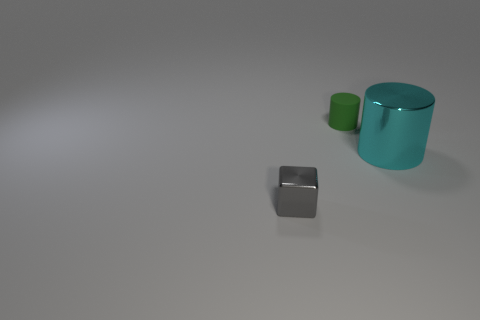The shiny thing that is right of the tiny object that is on the left side of the small green object is what color?
Offer a terse response. Cyan. What size is the object that is behind the tiny shiny cube and left of the large metallic cylinder?
Offer a very short reply. Small. Are there any other things of the same color as the large cylinder?
Your answer should be compact. No. The gray object that is the same material as the cyan cylinder is what shape?
Offer a very short reply. Cube. There is a rubber object; does it have the same shape as the metal thing behind the tiny block?
Keep it short and to the point. Yes. What is the material of the tiny thing behind the small object that is left of the tiny green rubber thing?
Make the answer very short. Rubber. Are there an equal number of gray things on the right side of the small gray cube and purple rubber cubes?
Offer a terse response. Yes. Is there anything else that has the same material as the green object?
Provide a short and direct response. No. There is a cylinder that is to the left of the cyan object; is its color the same as the metal object right of the gray cube?
Ensure brevity in your answer.  No. How many things are both in front of the green rubber cylinder and on the left side of the large cyan metal cylinder?
Give a very brief answer. 1. 